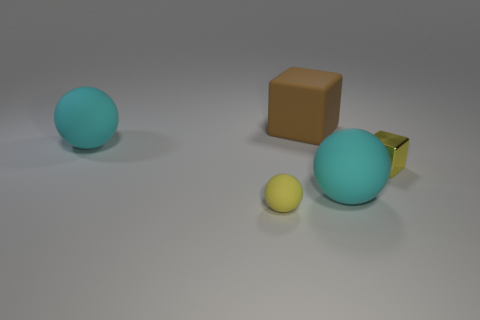There is a big rubber ball in front of the metal cube; does it have the same color as the small shiny cube in front of the brown object? No, the big rubber ball in front of the metal cube is a light blue shade, which contrasts with the small shiny cube in front of the brown object, as the small cube has a bright yellow color. 